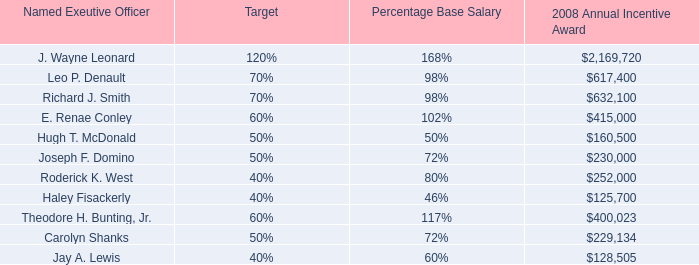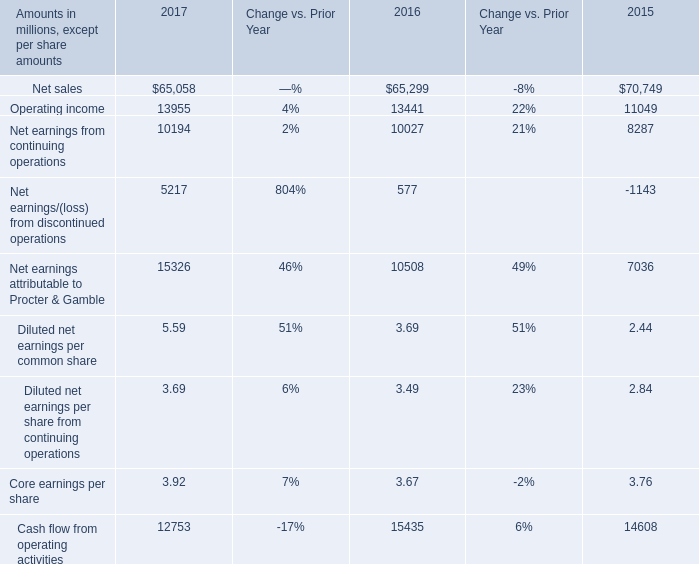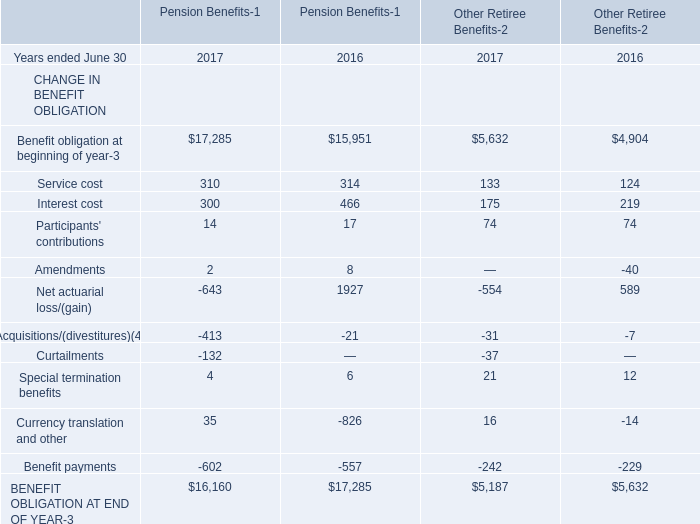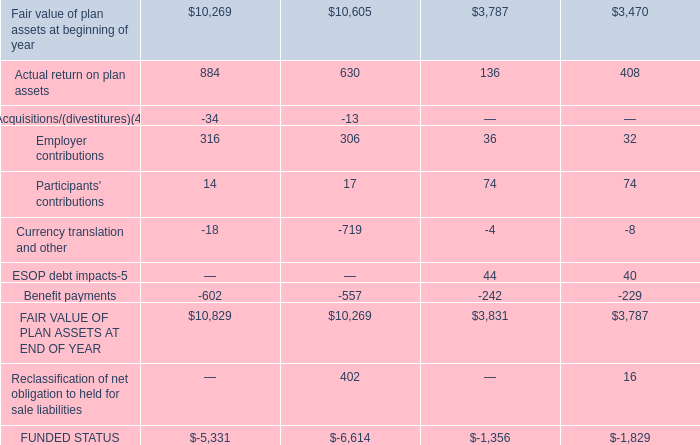What is the average amount of FAIR VALUE OF PLAN ASSETS AT END OF YEAR, and Richard J. Smith of 2008 Annual Incentive Award ? 
Computations: ((3831.0 + 632100.0) / 2)
Answer: 317965.5. 